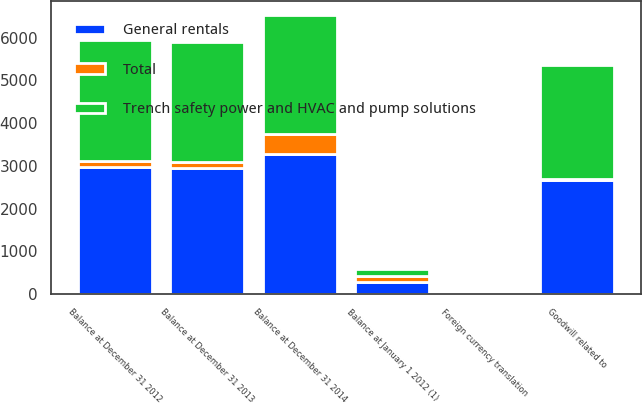Convert chart. <chart><loc_0><loc_0><loc_500><loc_500><stacked_bar_chart><ecel><fcel>Balance at January 1 2012 (1)<fcel>Goodwill related to<fcel>Balance at December 31 2012<fcel>Foreign currency translation<fcel>Balance at December 31 2013<fcel>Balance at December 31 2014<nl><fcel>Trench safety power and HVAC and pump solutions<fcel>167<fcel>2661<fcel>2828<fcel>16<fcel>2812<fcel>2804<nl><fcel>Total<fcel>122<fcel>20<fcel>142<fcel>1<fcel>141<fcel>468<nl><fcel>General rentals<fcel>289<fcel>2681<fcel>2970<fcel>17<fcel>2953<fcel>3272<nl></chart> 